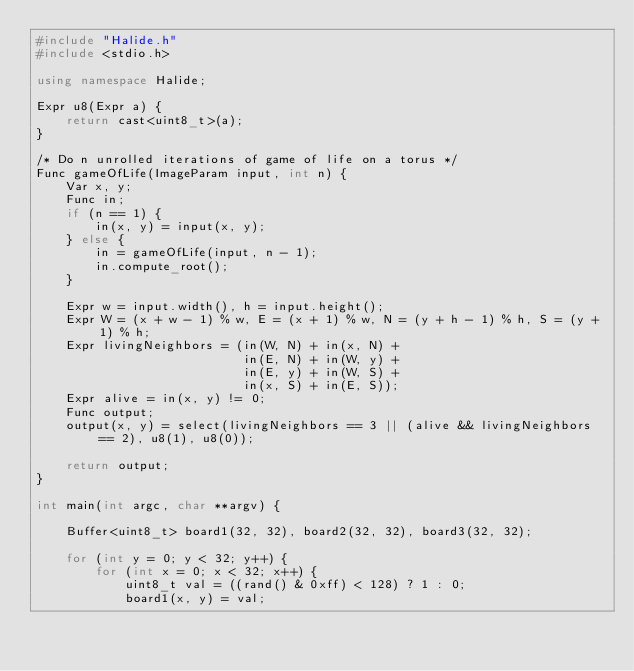<code> <loc_0><loc_0><loc_500><loc_500><_C++_>#include "Halide.h"
#include <stdio.h>

using namespace Halide;

Expr u8(Expr a) {
    return cast<uint8_t>(a);
}

/* Do n unrolled iterations of game of life on a torus */
Func gameOfLife(ImageParam input, int n) {
    Var x, y;
    Func in;
    if (n == 1) {
        in(x, y) = input(x, y);
    } else {
        in = gameOfLife(input, n - 1);
        in.compute_root();
    }

    Expr w = input.width(), h = input.height();
    Expr W = (x + w - 1) % w, E = (x + 1) % w, N = (y + h - 1) % h, S = (y + 1) % h;
    Expr livingNeighbors = (in(W, N) + in(x, N) +
                            in(E, N) + in(W, y) +
                            in(E, y) + in(W, S) +
                            in(x, S) + in(E, S));
    Expr alive = in(x, y) != 0;
    Func output;
    output(x, y) = select(livingNeighbors == 3 || (alive && livingNeighbors == 2), u8(1), u8(0));

    return output;
}

int main(int argc, char **argv) {

    Buffer<uint8_t> board1(32, 32), board2(32, 32), board3(32, 32);

    for (int y = 0; y < 32; y++) {
        for (int x = 0; x < 32; x++) {
            uint8_t val = ((rand() & 0xff) < 128) ? 1 : 0;
            board1(x, y) = val;</code> 